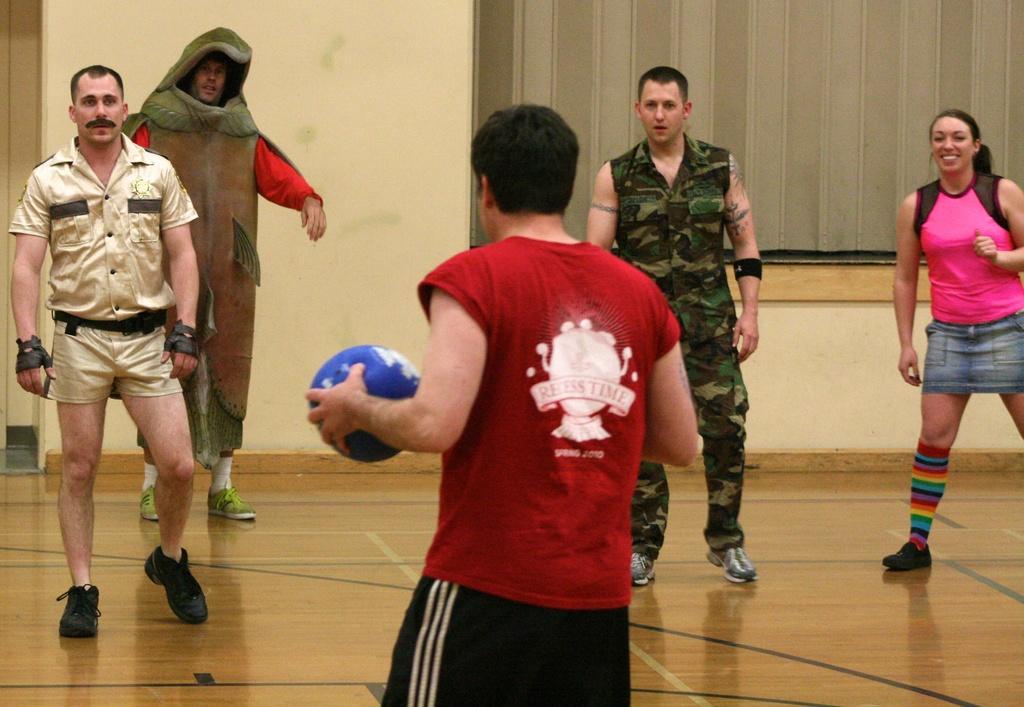How would you summarize this image in a sentence or two? This picture shows few people standing and a man holding a ball in his hand 